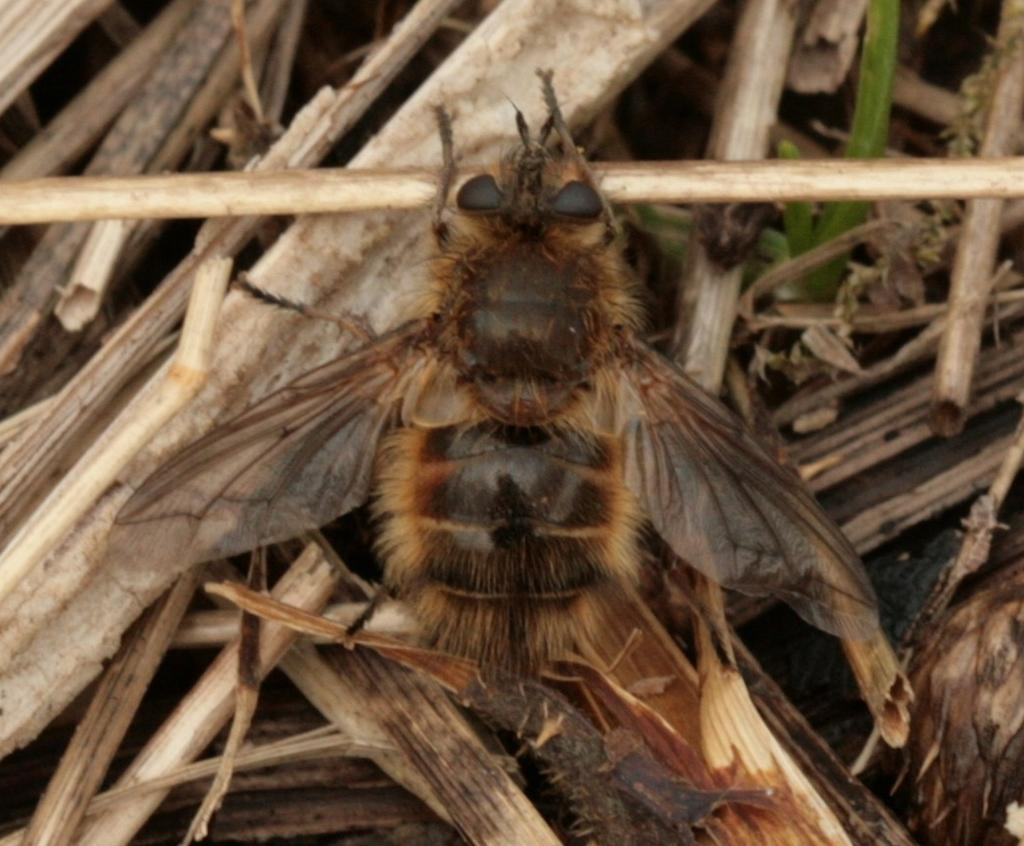What type of plant material is present in the image? There are dry plant sticks in the image. Can you describe any living organisms in the image? Yes, there is an insect in the image. What type of horse can be seen in the image? There is no horse present in the image; it features dry plant sticks and an insect. What type of test is being conducted in the image? There is no test being conducted in the image; it features dry plant sticks and an insect. 